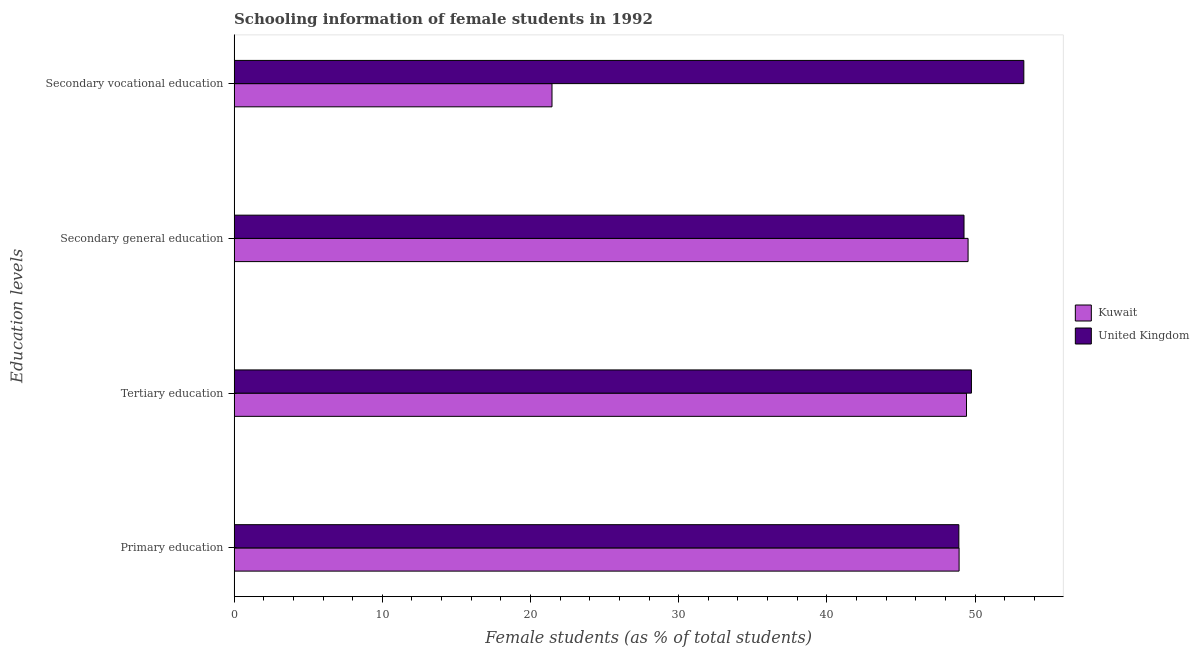How many different coloured bars are there?
Your response must be concise. 2. Are the number of bars on each tick of the Y-axis equal?
Provide a succinct answer. Yes. How many bars are there on the 1st tick from the bottom?
Your answer should be compact. 2. What is the label of the 3rd group of bars from the top?
Offer a very short reply. Tertiary education. What is the percentage of female students in tertiary education in Kuwait?
Offer a very short reply. 49.42. Across all countries, what is the maximum percentage of female students in secondary education?
Offer a terse response. 49.53. Across all countries, what is the minimum percentage of female students in primary education?
Provide a short and direct response. 48.91. In which country was the percentage of female students in primary education maximum?
Your answer should be compact. Kuwait. What is the total percentage of female students in secondary education in the graph?
Provide a short and direct response. 98.78. What is the difference between the percentage of female students in primary education in Kuwait and that in United Kingdom?
Ensure brevity in your answer.  0.02. What is the difference between the percentage of female students in secondary education in United Kingdom and the percentage of female students in primary education in Kuwait?
Keep it short and to the point. 0.33. What is the average percentage of female students in secondary education per country?
Provide a short and direct response. 49.39. What is the difference between the percentage of female students in tertiary education and percentage of female students in secondary education in United Kingdom?
Offer a terse response. 0.5. In how many countries, is the percentage of female students in tertiary education greater than 18 %?
Provide a short and direct response. 2. What is the ratio of the percentage of female students in secondary education in Kuwait to that in United Kingdom?
Ensure brevity in your answer.  1.01. What is the difference between the highest and the second highest percentage of female students in secondary vocational education?
Your response must be concise. 31.84. What is the difference between the highest and the lowest percentage of female students in primary education?
Your answer should be compact. 0.02. In how many countries, is the percentage of female students in secondary vocational education greater than the average percentage of female students in secondary vocational education taken over all countries?
Ensure brevity in your answer.  1. Is it the case that in every country, the sum of the percentage of female students in secondary vocational education and percentage of female students in tertiary education is greater than the sum of percentage of female students in primary education and percentage of female students in secondary education?
Your answer should be very brief. No. What does the 2nd bar from the top in Secondary vocational education represents?
Offer a very short reply. Kuwait. Is it the case that in every country, the sum of the percentage of female students in primary education and percentage of female students in tertiary education is greater than the percentage of female students in secondary education?
Keep it short and to the point. Yes. How many bars are there?
Keep it short and to the point. 8. Are all the bars in the graph horizontal?
Provide a succinct answer. Yes. What is the difference between two consecutive major ticks on the X-axis?
Your answer should be very brief. 10. Does the graph contain grids?
Keep it short and to the point. No. Where does the legend appear in the graph?
Offer a very short reply. Center right. What is the title of the graph?
Make the answer very short. Schooling information of female students in 1992. Does "Bermuda" appear as one of the legend labels in the graph?
Your answer should be very brief. No. What is the label or title of the X-axis?
Your answer should be compact. Female students (as % of total students). What is the label or title of the Y-axis?
Offer a very short reply. Education levels. What is the Female students (as % of total students) of Kuwait in Primary education?
Ensure brevity in your answer.  48.92. What is the Female students (as % of total students) of United Kingdom in Primary education?
Offer a very short reply. 48.91. What is the Female students (as % of total students) in Kuwait in Tertiary education?
Provide a short and direct response. 49.42. What is the Female students (as % of total students) in United Kingdom in Tertiary education?
Provide a succinct answer. 49.76. What is the Female students (as % of total students) in Kuwait in Secondary general education?
Keep it short and to the point. 49.53. What is the Female students (as % of total students) of United Kingdom in Secondary general education?
Your answer should be compact. 49.25. What is the Female students (as % of total students) in Kuwait in Secondary vocational education?
Provide a succinct answer. 21.45. What is the Female students (as % of total students) of United Kingdom in Secondary vocational education?
Your answer should be very brief. 53.29. Across all Education levels, what is the maximum Female students (as % of total students) of Kuwait?
Offer a very short reply. 49.53. Across all Education levels, what is the maximum Female students (as % of total students) of United Kingdom?
Give a very brief answer. 53.29. Across all Education levels, what is the minimum Female students (as % of total students) of Kuwait?
Your answer should be very brief. 21.45. Across all Education levels, what is the minimum Female students (as % of total students) in United Kingdom?
Your answer should be very brief. 48.91. What is the total Female students (as % of total students) in Kuwait in the graph?
Your answer should be compact. 169.32. What is the total Female students (as % of total students) of United Kingdom in the graph?
Provide a short and direct response. 201.21. What is the difference between the Female students (as % of total students) of Kuwait in Primary education and that in Tertiary education?
Provide a short and direct response. -0.5. What is the difference between the Female students (as % of total students) of United Kingdom in Primary education and that in Tertiary education?
Your response must be concise. -0.85. What is the difference between the Female students (as % of total students) in Kuwait in Primary education and that in Secondary general education?
Your answer should be very brief. -0.61. What is the difference between the Female students (as % of total students) of United Kingdom in Primary education and that in Secondary general education?
Give a very brief answer. -0.35. What is the difference between the Female students (as % of total students) of Kuwait in Primary education and that in Secondary vocational education?
Ensure brevity in your answer.  27.47. What is the difference between the Female students (as % of total students) of United Kingdom in Primary education and that in Secondary vocational education?
Offer a very short reply. -4.38. What is the difference between the Female students (as % of total students) of Kuwait in Tertiary education and that in Secondary general education?
Give a very brief answer. -0.11. What is the difference between the Female students (as % of total students) in United Kingdom in Tertiary education and that in Secondary general education?
Keep it short and to the point. 0.5. What is the difference between the Female students (as % of total students) in Kuwait in Tertiary education and that in Secondary vocational education?
Make the answer very short. 27.97. What is the difference between the Female students (as % of total students) in United Kingdom in Tertiary education and that in Secondary vocational education?
Offer a terse response. -3.54. What is the difference between the Female students (as % of total students) of Kuwait in Secondary general education and that in Secondary vocational education?
Your response must be concise. 28.08. What is the difference between the Female students (as % of total students) in United Kingdom in Secondary general education and that in Secondary vocational education?
Offer a very short reply. -4.04. What is the difference between the Female students (as % of total students) in Kuwait in Primary education and the Female students (as % of total students) in United Kingdom in Tertiary education?
Offer a very short reply. -0.83. What is the difference between the Female students (as % of total students) in Kuwait in Primary education and the Female students (as % of total students) in United Kingdom in Secondary general education?
Ensure brevity in your answer.  -0.33. What is the difference between the Female students (as % of total students) of Kuwait in Primary education and the Female students (as % of total students) of United Kingdom in Secondary vocational education?
Your answer should be compact. -4.37. What is the difference between the Female students (as % of total students) of Kuwait in Tertiary education and the Female students (as % of total students) of United Kingdom in Secondary general education?
Your answer should be compact. 0.17. What is the difference between the Female students (as % of total students) of Kuwait in Tertiary education and the Female students (as % of total students) of United Kingdom in Secondary vocational education?
Your answer should be very brief. -3.87. What is the difference between the Female students (as % of total students) in Kuwait in Secondary general education and the Female students (as % of total students) in United Kingdom in Secondary vocational education?
Keep it short and to the point. -3.76. What is the average Female students (as % of total students) in Kuwait per Education levels?
Your answer should be compact. 42.33. What is the average Female students (as % of total students) in United Kingdom per Education levels?
Keep it short and to the point. 50.3. What is the difference between the Female students (as % of total students) of Kuwait and Female students (as % of total students) of United Kingdom in Primary education?
Your answer should be very brief. 0.02. What is the difference between the Female students (as % of total students) of Kuwait and Female students (as % of total students) of United Kingdom in Tertiary education?
Your answer should be very brief. -0.33. What is the difference between the Female students (as % of total students) of Kuwait and Female students (as % of total students) of United Kingdom in Secondary general education?
Give a very brief answer. 0.27. What is the difference between the Female students (as % of total students) of Kuwait and Female students (as % of total students) of United Kingdom in Secondary vocational education?
Offer a very short reply. -31.84. What is the ratio of the Female students (as % of total students) in United Kingdom in Primary education to that in Tertiary education?
Your response must be concise. 0.98. What is the ratio of the Female students (as % of total students) of Kuwait in Primary education to that in Secondary vocational education?
Give a very brief answer. 2.28. What is the ratio of the Female students (as % of total students) of United Kingdom in Primary education to that in Secondary vocational education?
Make the answer very short. 0.92. What is the ratio of the Female students (as % of total students) in United Kingdom in Tertiary education to that in Secondary general education?
Your answer should be very brief. 1.01. What is the ratio of the Female students (as % of total students) of Kuwait in Tertiary education to that in Secondary vocational education?
Your answer should be very brief. 2.3. What is the ratio of the Female students (as % of total students) in United Kingdom in Tertiary education to that in Secondary vocational education?
Ensure brevity in your answer.  0.93. What is the ratio of the Female students (as % of total students) of Kuwait in Secondary general education to that in Secondary vocational education?
Ensure brevity in your answer.  2.31. What is the ratio of the Female students (as % of total students) in United Kingdom in Secondary general education to that in Secondary vocational education?
Your answer should be compact. 0.92. What is the difference between the highest and the second highest Female students (as % of total students) in Kuwait?
Offer a terse response. 0.11. What is the difference between the highest and the second highest Female students (as % of total students) of United Kingdom?
Your answer should be very brief. 3.54. What is the difference between the highest and the lowest Female students (as % of total students) in Kuwait?
Give a very brief answer. 28.08. What is the difference between the highest and the lowest Female students (as % of total students) in United Kingdom?
Provide a short and direct response. 4.38. 